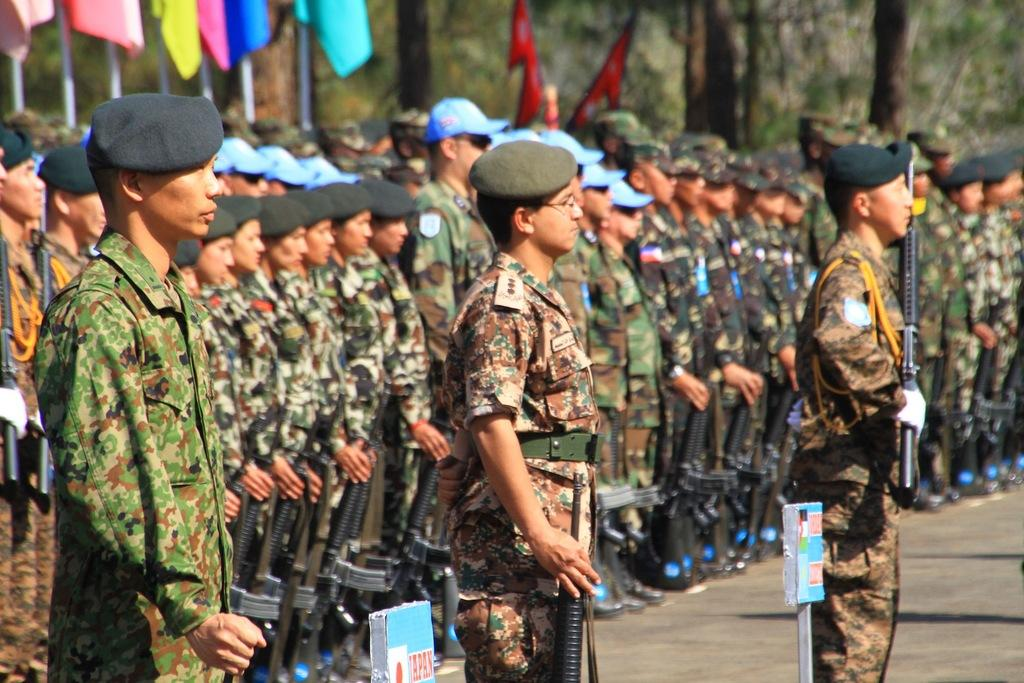How many people are in the image? There are people in the image, but the exact number is not specified. What type of clothing are the people wearing? The people are wearing military dressesque dresses and caps. What are the people holding in the image? The people are holding guns. What can be seen in the background of the image? The background of the image includes flags, trees, boards, and rods. What type of drug can be seen in the hands of the people in the image? There is no drug present in the image; the people are holding guns. Can you tell me how many partners are visible in the image? There is no mention of partners in the image; it features people wearing military dressesque dresses and holding guns. 